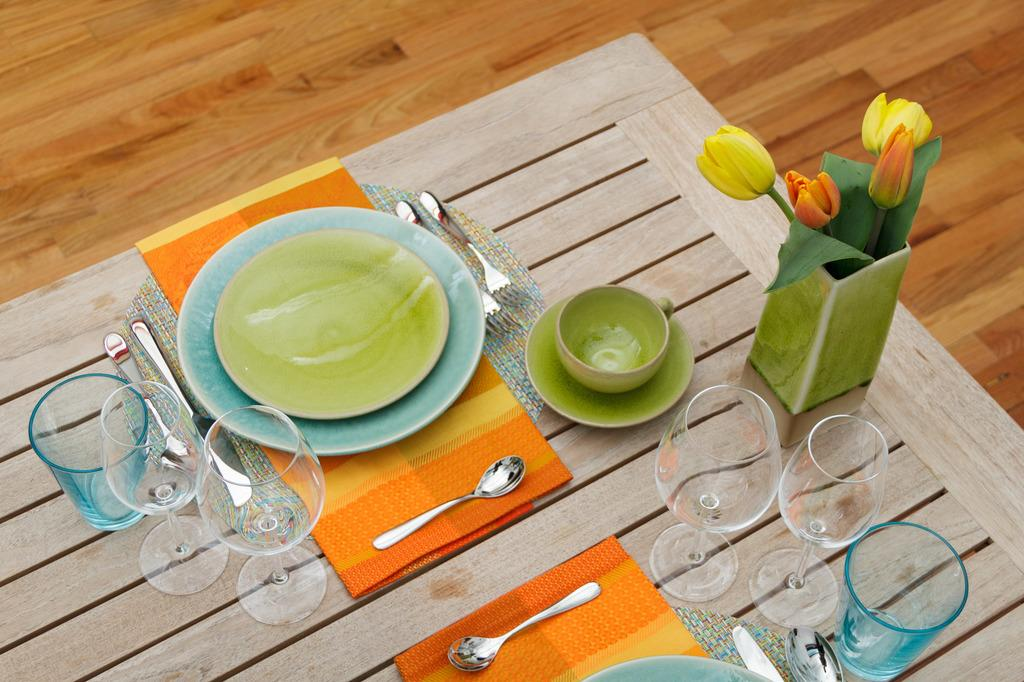What type of table is in the image? There is a wooden table in the image. What objects are placed on the table? There are plates, glasses, flowers, and spoons on the table. What might be used for eating or drinking in the image? Plates and glasses are present on the table for eating and drinking. What type of decoration is on the table? There are flowers on the table as decoration. How many eggs are on the table in the image? There is no mention of eggs in the image; the provided facts only mention plates, glasses, flowers, and spoons on the table. 